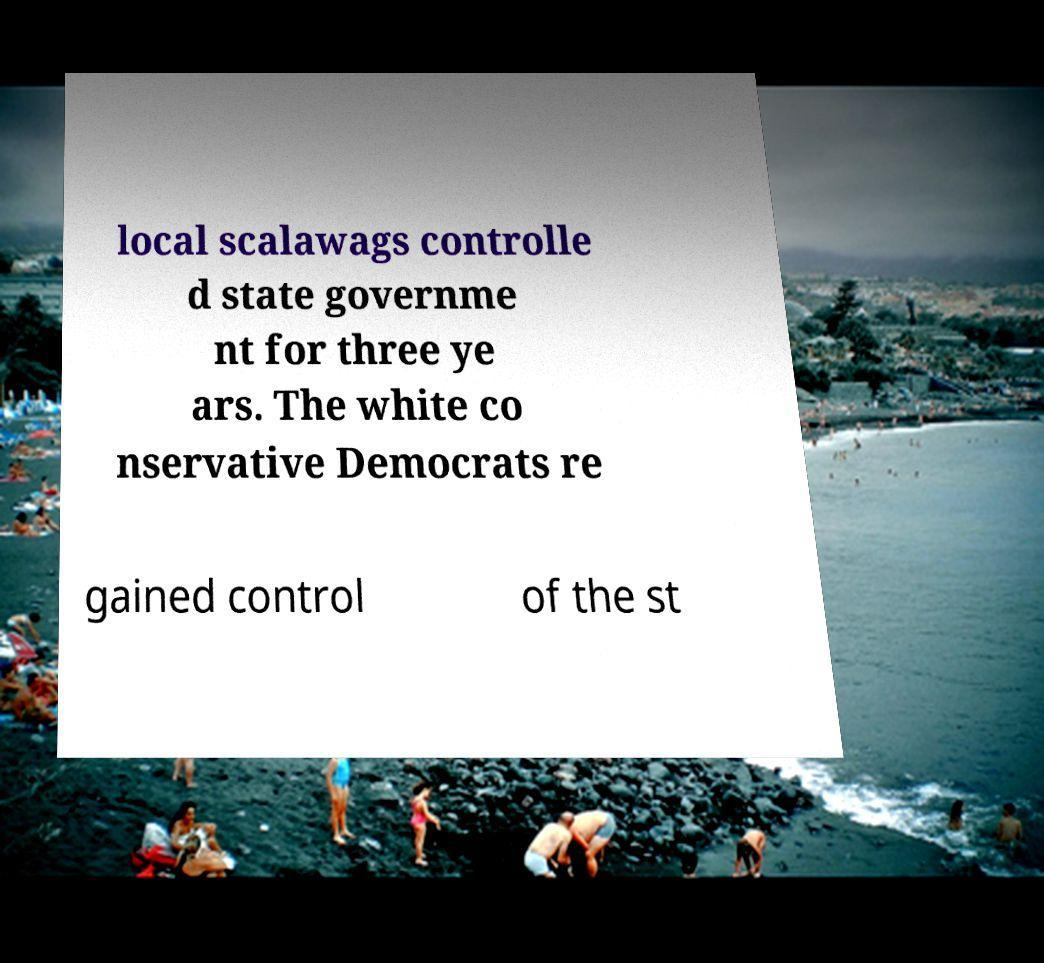Can you accurately transcribe the text from the provided image for me? local scalawags controlle d state governme nt for three ye ars. The white co nservative Democrats re gained control of the st 